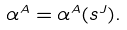<formula> <loc_0><loc_0><loc_500><loc_500>\alpha ^ { A } = \alpha ^ { A } ( s ^ { J } ) .</formula> 